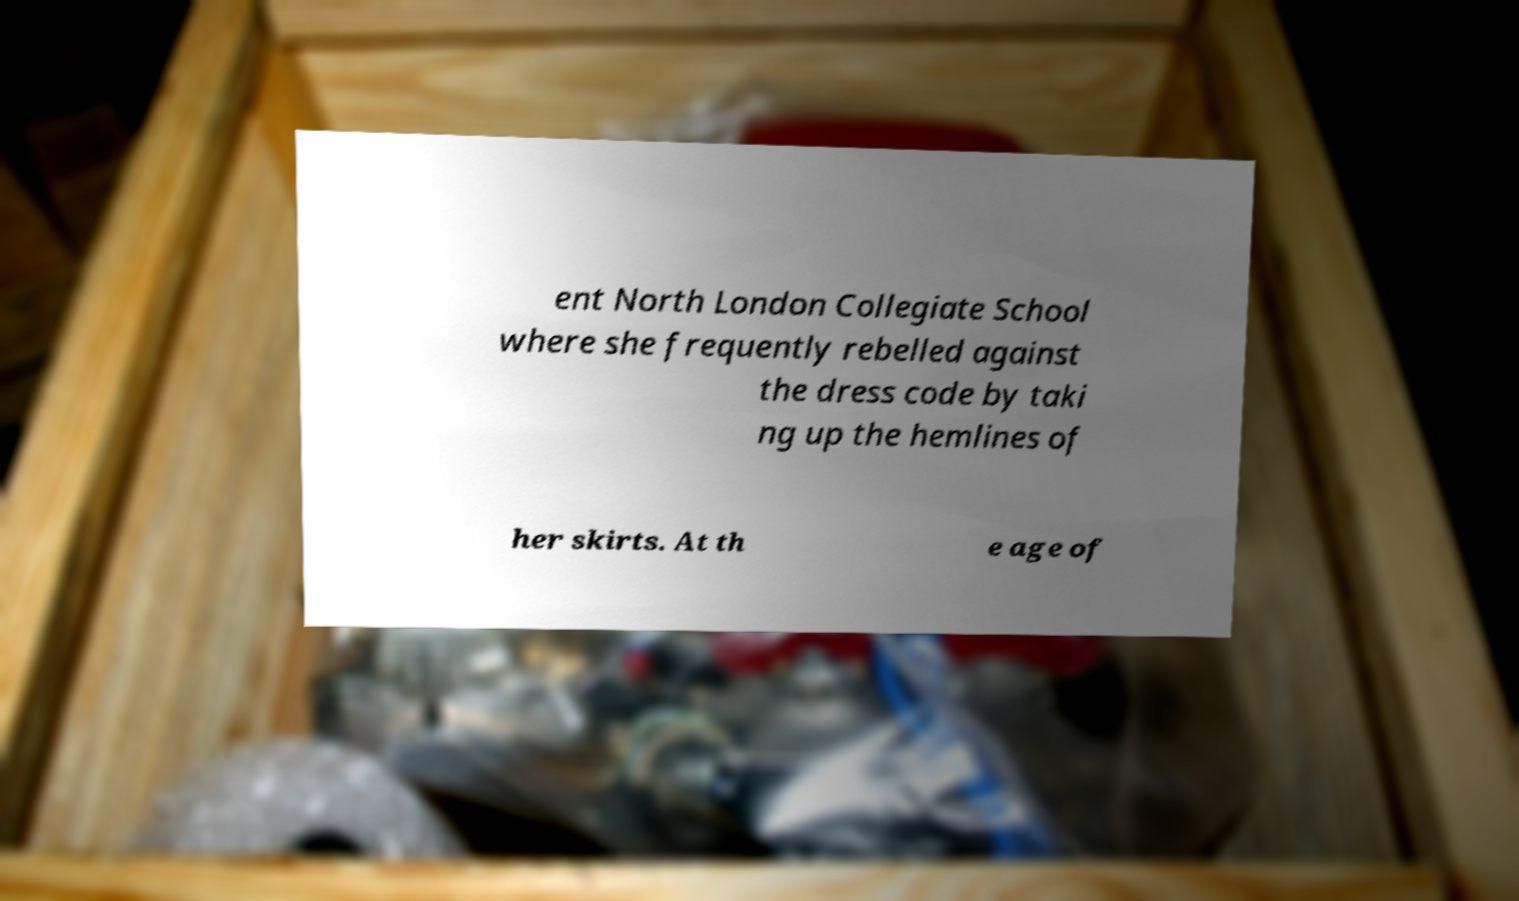Can you accurately transcribe the text from the provided image for me? ent North London Collegiate School where she frequently rebelled against the dress code by taki ng up the hemlines of her skirts. At th e age of 